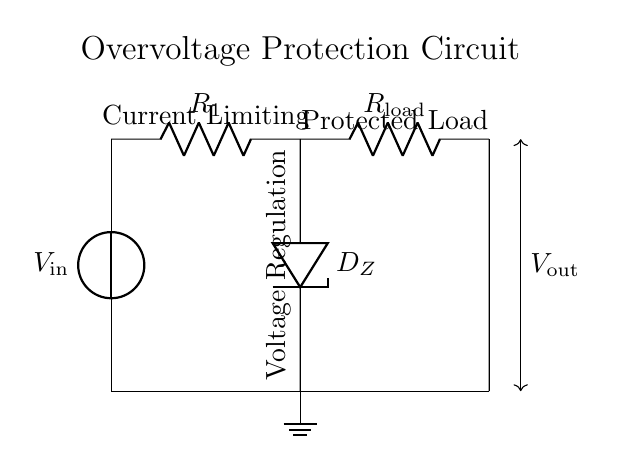What type of diode is used in this circuit? The circuit uses a Zener diode, indicated by the label D_Z. Zener diodes are specifically designed to operate in reverse breakdown mode, which is essential for voltage regulation and overvoltage protection.
Answer: Zener diode What is the function of the resistor labeled R_1? The resistor R_1 is used for current limiting. It restricts the amount of current that flows to the load and the Zener diode, preventing excessive current which could damage sensitive components in the circuit.
Answer: Current limiting What role does the Zener diode play in this circuit? The Zener diode regulates the output voltage by allowing current to flow in reverse once the input voltage exceeds a specific threshold (Zener voltage). This prevents the voltage across the load from exceeding a certain level, protecting the load from overvoltage conditions.
Answer: Voltage regulation What is the expected output voltage represented in this circuit? The output voltage V_out will be approximately equal to the Zener voltage of the diode D_Z when the input voltage exceeds this threshold. The exact value depends on the specifications of the Zener diode used in the circuit design.
Answer: Zener voltage How does the circuit ensure the load is protected from overvoltage? The circuit uses the Zener diode to clamp the voltage across the load. When the input voltage surpasses the Zener breakdown voltage, the diode conducts, shunting excess current away from the load and keeping the output voltage at a safe level.
Answer: By clamping voltage 